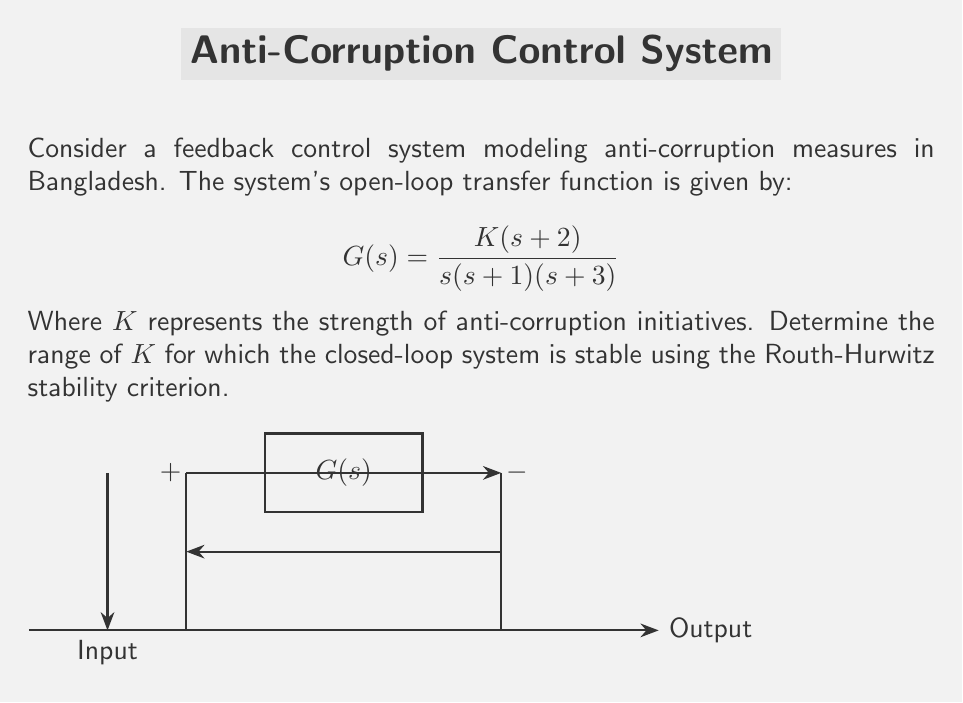What is the answer to this math problem? To analyze the stability of the closed-loop system, we follow these steps:

1) The closed-loop transfer function is:
   $$T(s) = \frac{G(s)}{1+G(s)} = \frac{K(s+2)}{s(s+1)(s+3) + K(s+2)}$$

2) The characteristic equation is:
   $$s(s+1)(s+3) + K(s+2) = 0$$
   $$s^3 + 4s^2 + 3s + K(s+2) = 0$$
   $$s^3 + 4s^2 + (3+K)s + 2K = 0$$

3) Now, we construct the Routh array:
   $$\begin{array}{c|c}
   s^3 & 1 & 3+K \\
   s^2 & 4 & 2K \\
   s^1 & \frac{(3+K)4 - 2K}{4} & 0 \\
   s^0 & 2K & 0
   \end{array}$$

4) For stability, all elements in the first column must be positive. We already know 1 and 4 are positive, so we need:

   $$\frac{(3+K)4 - 2K}{4} > 0 \quad \text{and} \quad 2K > 0$$

5) From $2K > 0$, we get $K > 0$.

6) From $\frac{(3+K)4 - 2K}{4} > 0$:
   $$12 + 4K - 2K > 0$$
   $$12 + 2K > 0$$
   $$K > -6$$

7) Combining the conditions from steps 5 and 6, we get:
   $$K > 0$$

Therefore, the system is stable for all $K > 0$.
Answer: $K > 0$ 